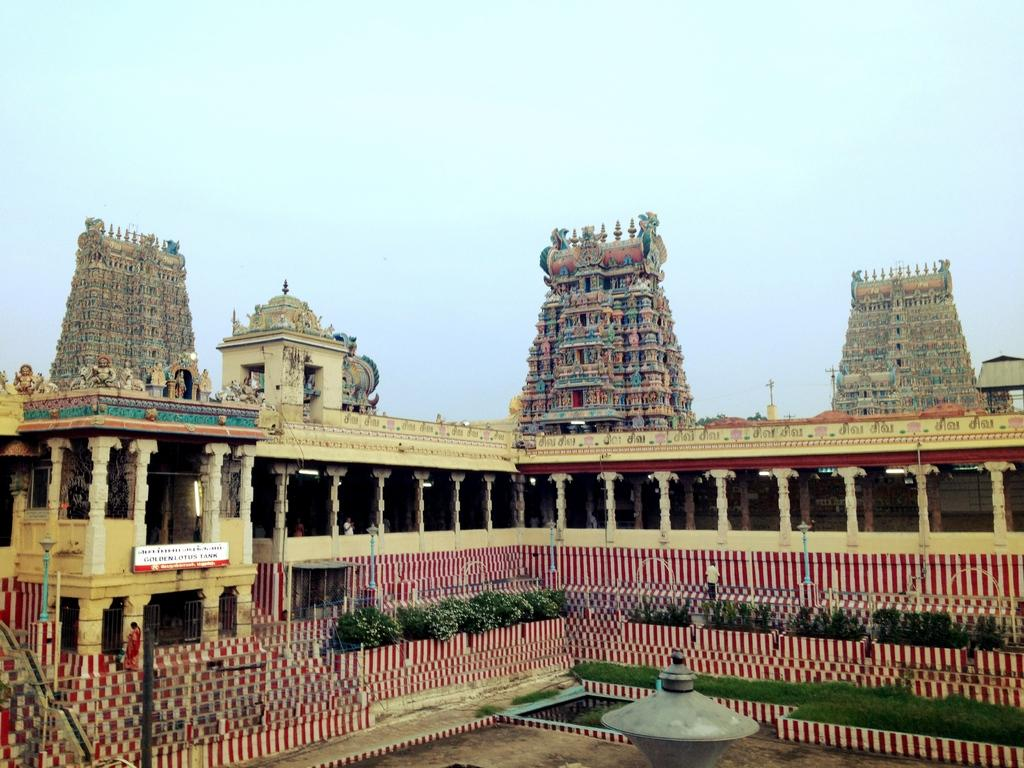What type of building is in the picture? There is a temple in the picture. What can be seen inside or around the temple? There is some sculpture in the picture. What type of vegetation is present in the image? There are plants in the picture. What architectural feature is visible in the image? There are stairs in the picture. What is the condition of the sky in the picture? The sky is clear in the picture. What type of protest is happening in the picture? There is no protest present in the image; it features a temple with sculpture, plants, stairs, and a clear sky. What type of care is being provided to the temple in the picture? There is no indication of care being provided to the temple in the image; it simply shows the temple and its surroundings. 